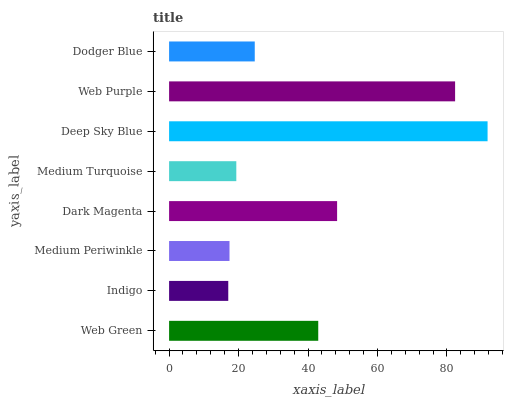Is Indigo the minimum?
Answer yes or no. Yes. Is Deep Sky Blue the maximum?
Answer yes or no. Yes. Is Medium Periwinkle the minimum?
Answer yes or no. No. Is Medium Periwinkle the maximum?
Answer yes or no. No. Is Medium Periwinkle greater than Indigo?
Answer yes or no. Yes. Is Indigo less than Medium Periwinkle?
Answer yes or no. Yes. Is Indigo greater than Medium Periwinkle?
Answer yes or no. No. Is Medium Periwinkle less than Indigo?
Answer yes or no. No. Is Web Green the high median?
Answer yes or no. Yes. Is Dodger Blue the low median?
Answer yes or no. Yes. Is Dark Magenta the high median?
Answer yes or no. No. Is Dark Magenta the low median?
Answer yes or no. No. 